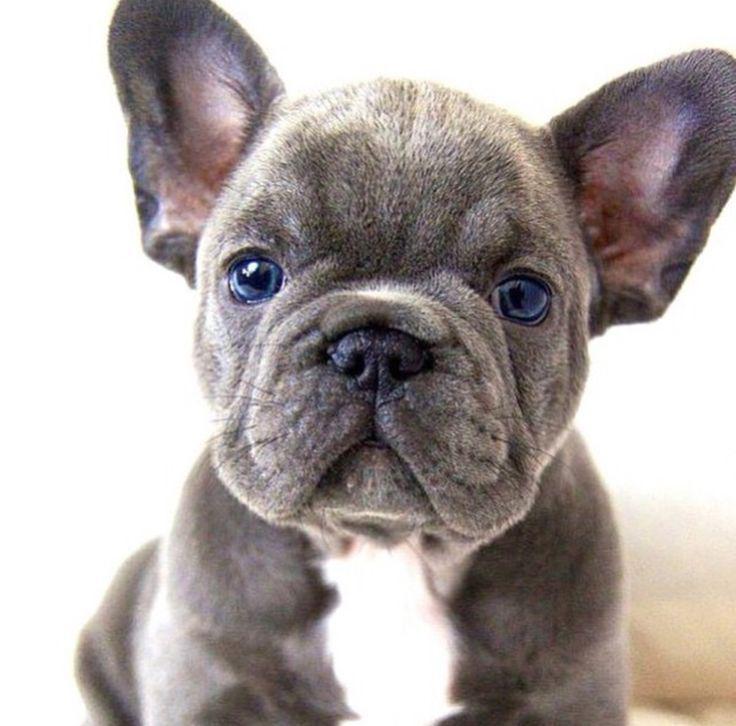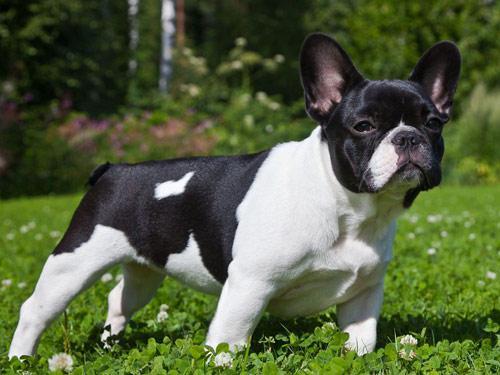The first image is the image on the left, the second image is the image on the right. Given the left and right images, does the statement "An image shows a gray dog with a white mark on its chest." hold true? Answer yes or no. Yes. 